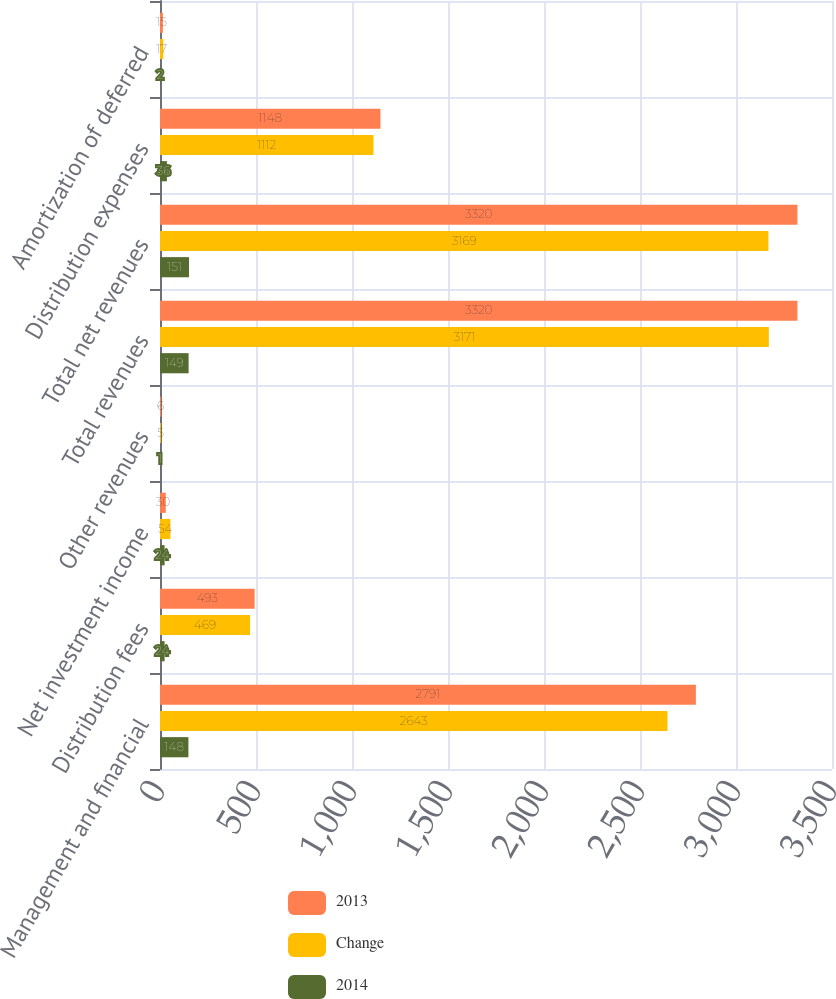<chart> <loc_0><loc_0><loc_500><loc_500><stacked_bar_chart><ecel><fcel>Management and financial<fcel>Distribution fees<fcel>Net investment income<fcel>Other revenues<fcel>Total revenues<fcel>Total net revenues<fcel>Distribution expenses<fcel>Amortization of deferred<nl><fcel>2013<fcel>2791<fcel>493<fcel>30<fcel>6<fcel>3320<fcel>3320<fcel>1148<fcel>15<nl><fcel>Change<fcel>2643<fcel>469<fcel>54<fcel>5<fcel>3171<fcel>3169<fcel>1112<fcel>17<nl><fcel>2014<fcel>148<fcel>24<fcel>24<fcel>1<fcel>149<fcel>151<fcel>36<fcel>2<nl></chart> 